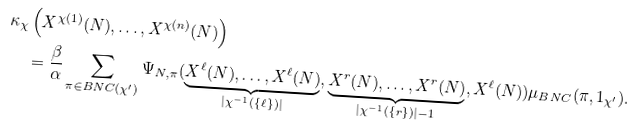Convert formula to latex. <formula><loc_0><loc_0><loc_500><loc_500>\kappa _ { \chi } & \left ( X ^ { \chi ( 1 ) } ( N ) , \dots , X ^ { \chi ( n ) } ( N ) \right ) \\ & = \frac { \beta } { \alpha } \sum _ { \pi \in B N C ( \chi ^ { \prime } ) } \Psi _ { N , \pi } ( \underbrace { X ^ { \ell } ( N ) , \dots , X ^ { \ell } ( N ) } _ { | \chi ^ { - 1 } ( \{ \ell \} ) | } , \underbrace { X ^ { r } ( N ) , \dots , X ^ { r } ( N ) } _ { | \chi ^ { - 1 } ( \{ r \} ) | - 1 } , X ^ { \ell } ( N ) ) \mu _ { B N C } ( \pi , 1 _ { \chi ^ { \prime } } ) .</formula> 